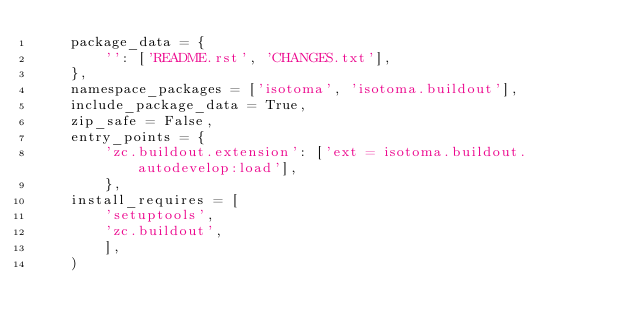Convert code to text. <code><loc_0><loc_0><loc_500><loc_500><_Python_>    package_data = {
        '': ['README.rst', 'CHANGES.txt'],
    },
    namespace_packages = ['isotoma', 'isotoma.buildout'],
    include_package_data = True,
    zip_safe = False,
    entry_points = {
        'zc.buildout.extension': ['ext = isotoma.buildout.autodevelop:load'],
        },
    install_requires = [
        'setuptools',
        'zc.buildout',
        ],
    )

</code> 